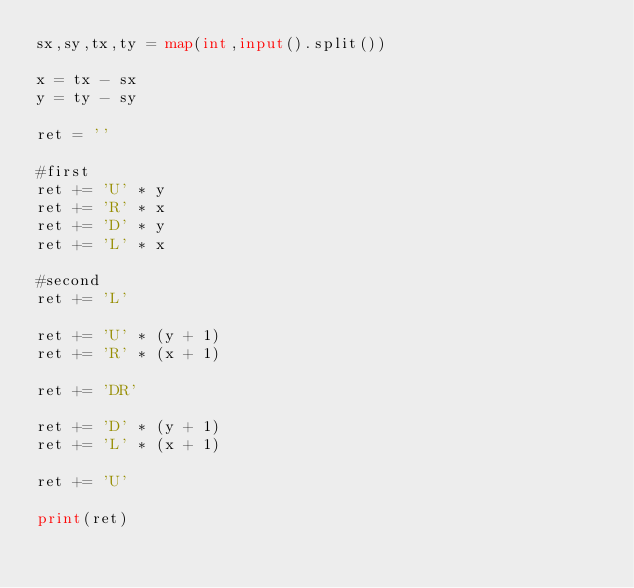Convert code to text. <code><loc_0><loc_0><loc_500><loc_500><_Python_>sx,sy,tx,ty = map(int,input().split())

x = tx - sx
y = ty - sy

ret = ''

#first
ret += 'U' * y
ret += 'R' * x
ret += 'D' * y
ret += 'L' * x

#second
ret += 'L'

ret += 'U' * (y + 1)
ret += 'R' * (x + 1)

ret += 'DR'

ret += 'D' * (y + 1)
ret += 'L' * (x + 1)

ret += 'U'

print(ret)
</code> 